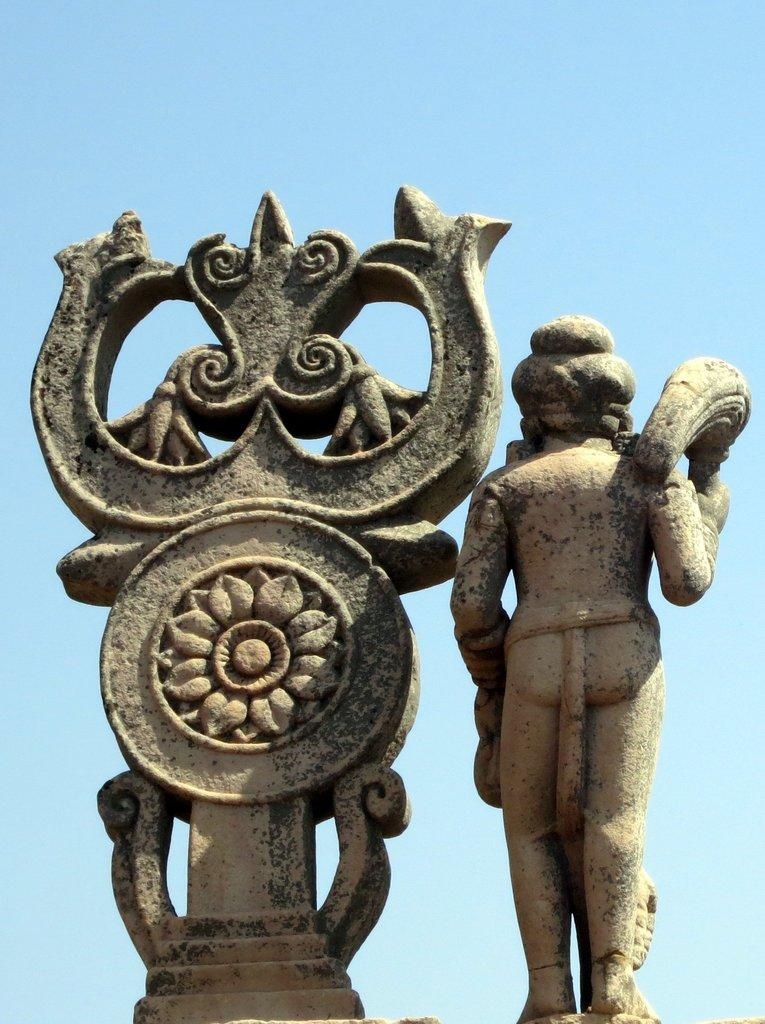What type of objects can be seen in the middle of the image? There are statues in the image. Can you describe the location of the statues in the image? The statues are located in the middle of the image. What color is the line on the skin of the statues in the image? There is no line or skin present on the statues in the image, as they are likely made of stone or another inanimate material. 